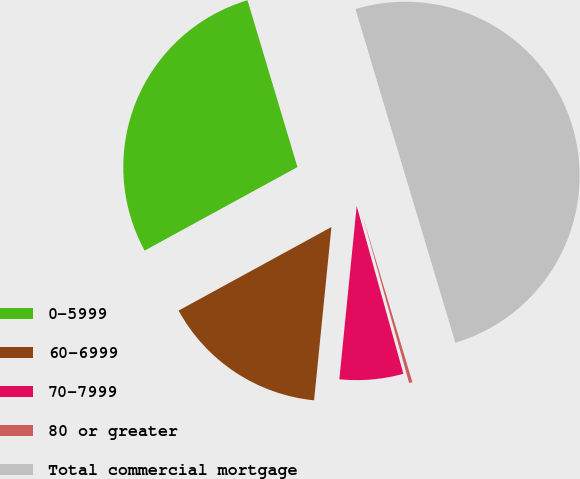<chart> <loc_0><loc_0><loc_500><loc_500><pie_chart><fcel>0-5999<fcel>60-6999<fcel>70-7999<fcel>80 or greater<fcel>Total commercial mortgage<nl><fcel>28.33%<fcel>15.45%<fcel>5.91%<fcel>0.31%<fcel>50.0%<nl></chart> 